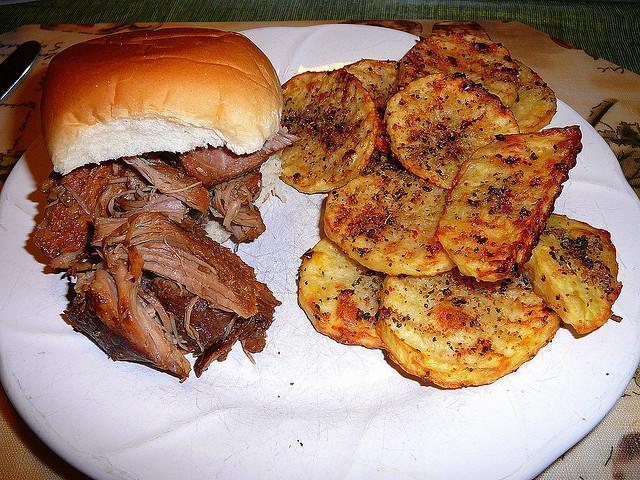The item on the right is most likely a cooked version of what?
Make your selection and explain in format: 'Answer: answer
Rationale: rationale.'
Options: Potato, carrot, orange, lemon. Answer: potato.
Rationale: The potatoes are sliced and fried. 